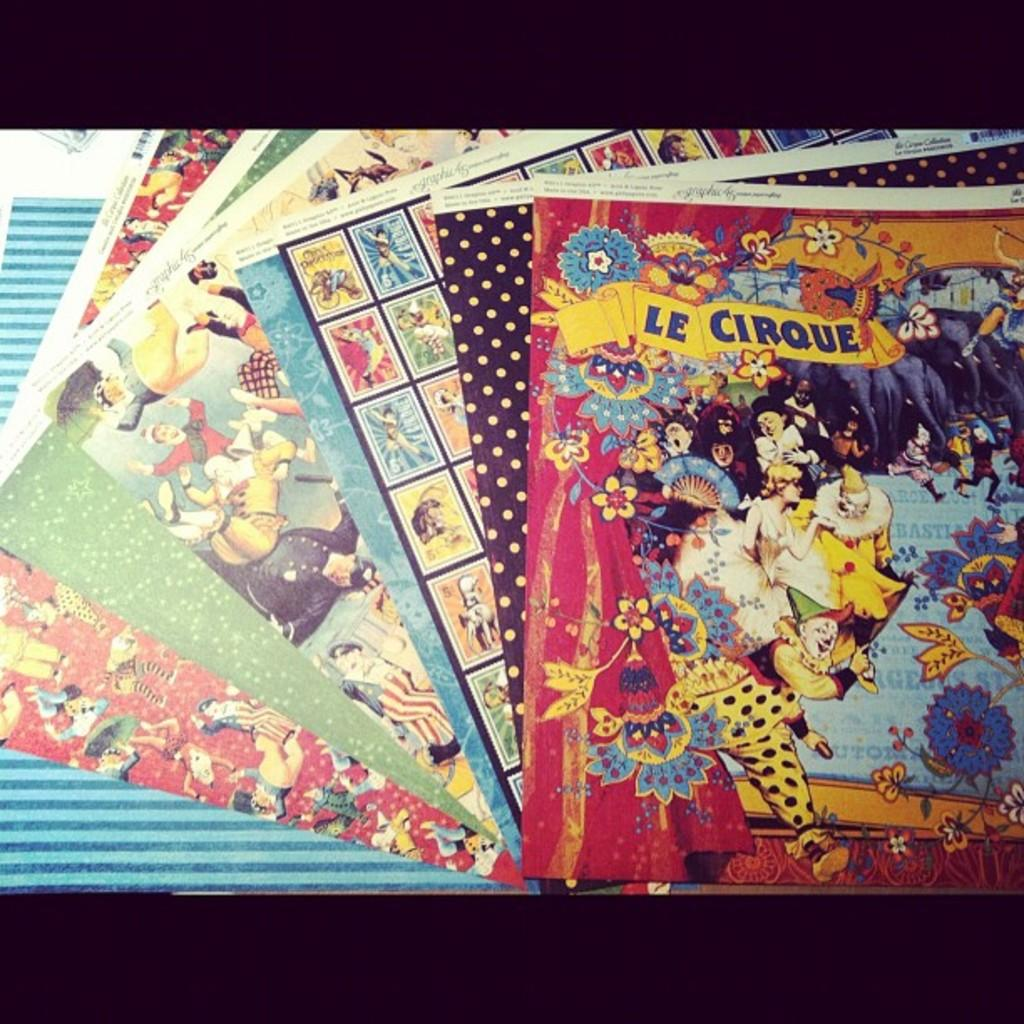<image>
Describe the image concisely. A collection of booklets sit on a table with the top book titled LE CIRQUE. 